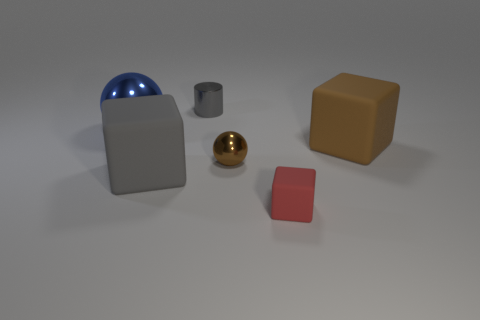Add 2 small rubber objects. How many objects exist? 8 Subtract all cylinders. How many objects are left? 5 Subtract 0 purple cylinders. How many objects are left? 6 Subtract all large gray cylinders. Subtract all red blocks. How many objects are left? 5 Add 5 rubber blocks. How many rubber blocks are left? 8 Add 2 large matte things. How many large matte things exist? 4 